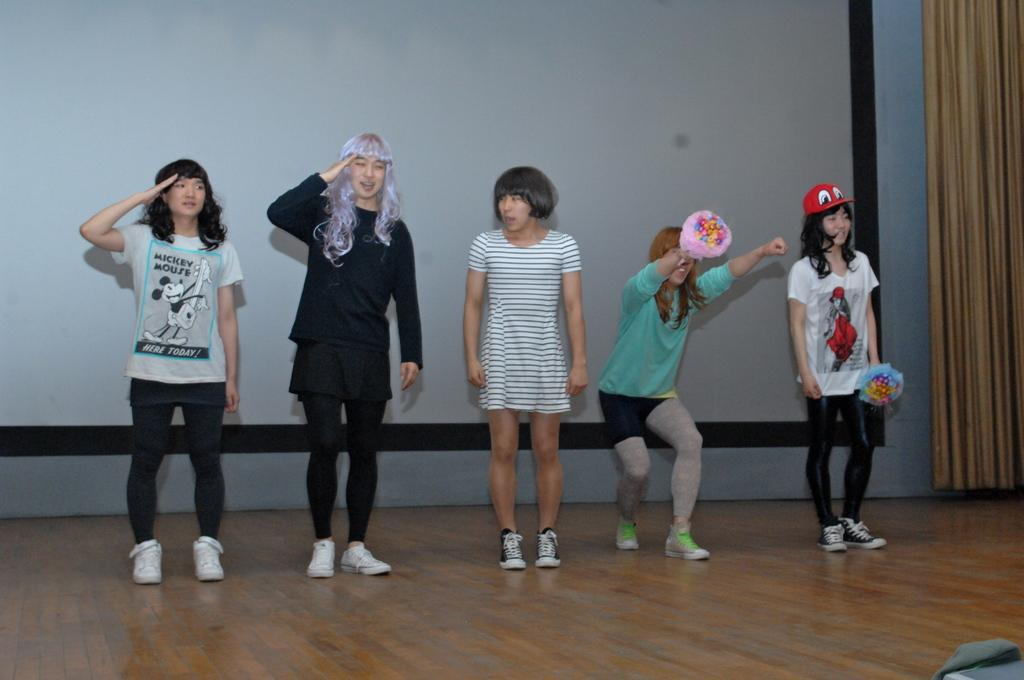How many people are in the image? There is a group of people in the image. What type of flooring is visible in the image? The people are standing on a wooden floor. What are some people holding in the image? Some people are holding objects. What is the facial expression of the people in the image? The people are smiling. What can be seen in the background of the image? There is a wall and a curtain in the background of the image. What type of jail can be seen in the background of the image? There is no jail present in the image; it features a group of people standing on a wooden floor with a wall and curtain in the background. How many boys are visible in the image? The provided facts do not specify the gender of the people in the image, so it cannot be determined how many boys are visible. 